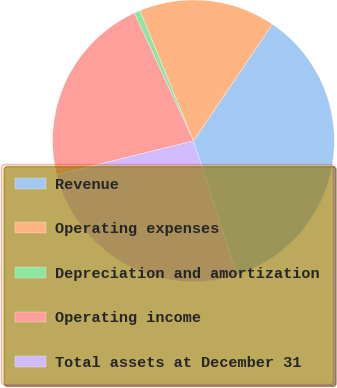Convert chart to OTSL. <chart><loc_0><loc_0><loc_500><loc_500><pie_chart><fcel>Revenue<fcel>Operating expenses<fcel>Depreciation and amortization<fcel>Operating income<fcel>Total assets at December 31<nl><fcel>35.54%<fcel>15.68%<fcel>0.69%<fcel>21.97%<fcel>26.13%<nl></chart> 